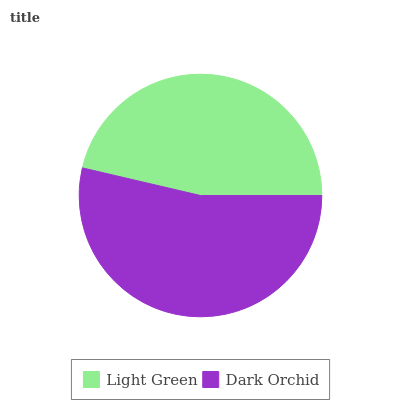Is Light Green the minimum?
Answer yes or no. Yes. Is Dark Orchid the maximum?
Answer yes or no. Yes. Is Dark Orchid the minimum?
Answer yes or no. No. Is Dark Orchid greater than Light Green?
Answer yes or no. Yes. Is Light Green less than Dark Orchid?
Answer yes or no. Yes. Is Light Green greater than Dark Orchid?
Answer yes or no. No. Is Dark Orchid less than Light Green?
Answer yes or no. No. Is Dark Orchid the high median?
Answer yes or no. Yes. Is Light Green the low median?
Answer yes or no. Yes. Is Light Green the high median?
Answer yes or no. No. Is Dark Orchid the low median?
Answer yes or no. No. 